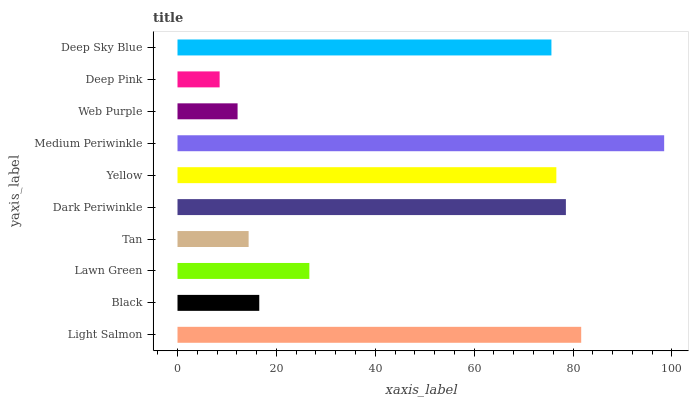Is Deep Pink the minimum?
Answer yes or no. Yes. Is Medium Periwinkle the maximum?
Answer yes or no. Yes. Is Black the minimum?
Answer yes or no. No. Is Black the maximum?
Answer yes or no. No. Is Light Salmon greater than Black?
Answer yes or no. Yes. Is Black less than Light Salmon?
Answer yes or no. Yes. Is Black greater than Light Salmon?
Answer yes or no. No. Is Light Salmon less than Black?
Answer yes or no. No. Is Deep Sky Blue the high median?
Answer yes or no. Yes. Is Lawn Green the low median?
Answer yes or no. Yes. Is Light Salmon the high median?
Answer yes or no. No. Is Light Salmon the low median?
Answer yes or no. No. 